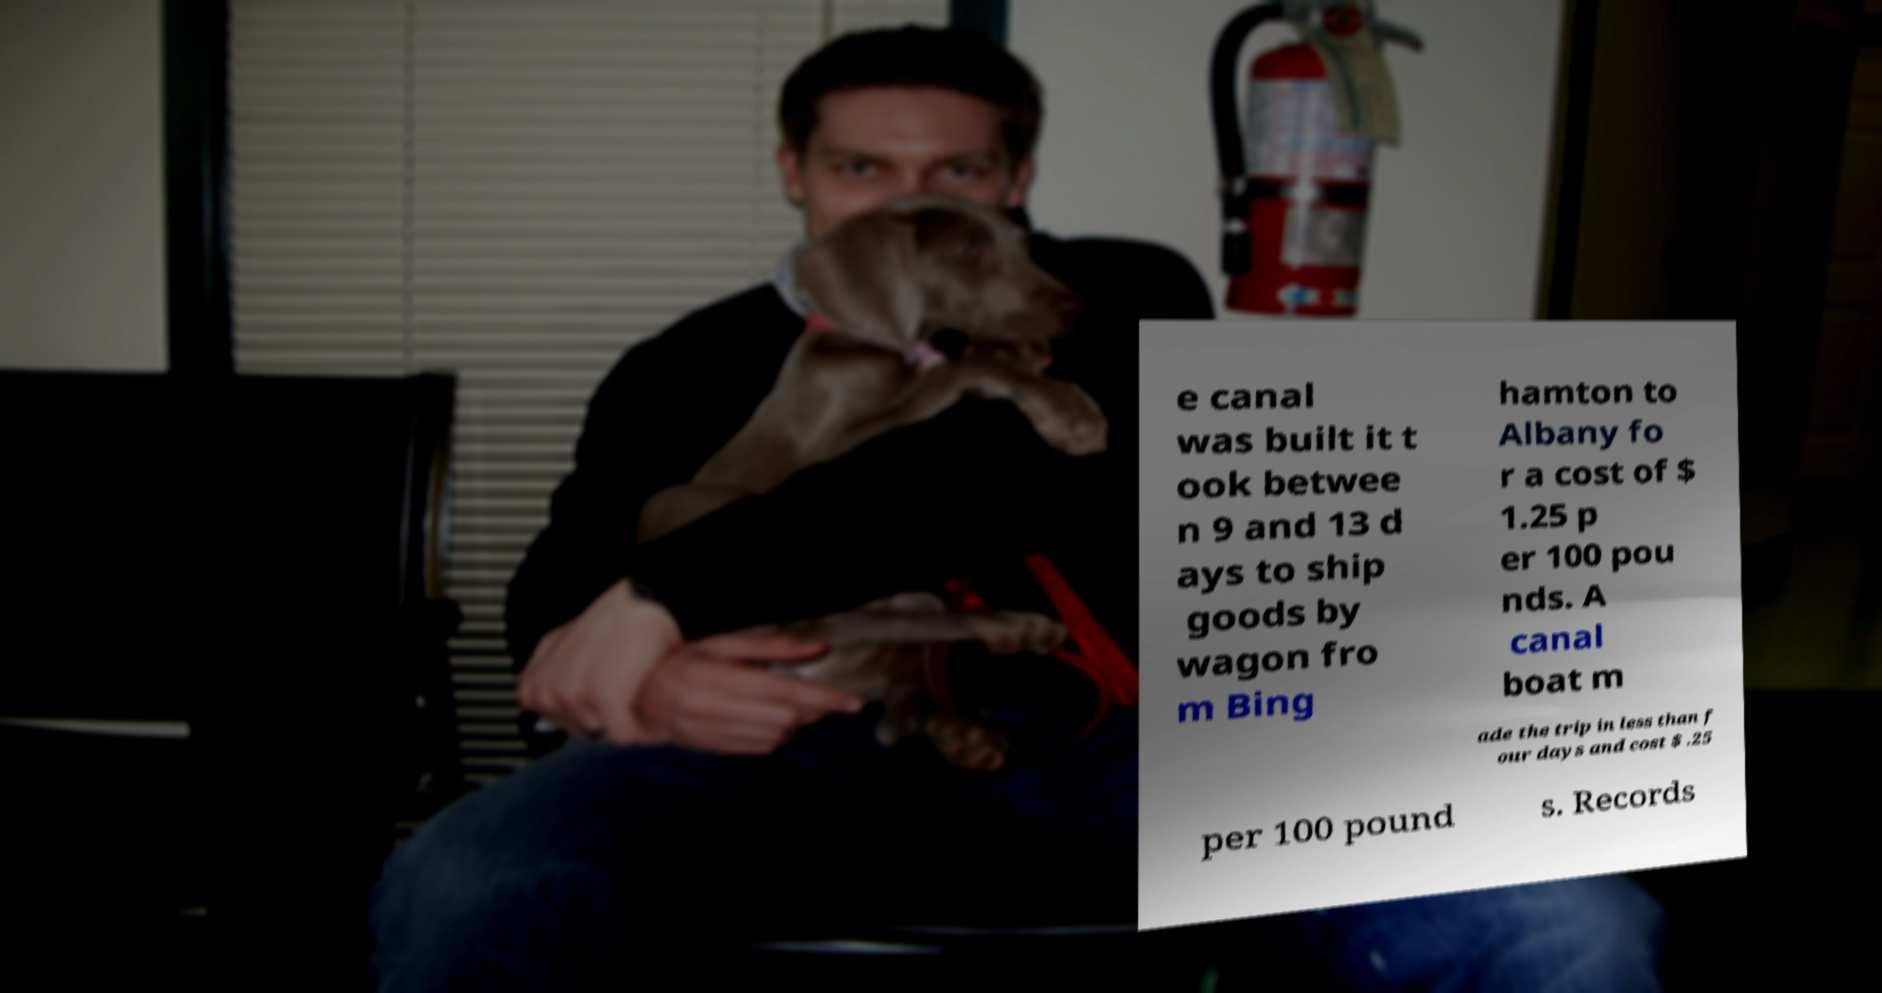Can you accurately transcribe the text from the provided image for me? e canal was built it t ook betwee n 9 and 13 d ays to ship goods by wagon fro m Bing hamton to Albany fo r a cost of $ 1.25 p er 100 pou nds. A canal boat m ade the trip in less than f our days and cost $ .25 per 100 pound s. Records 